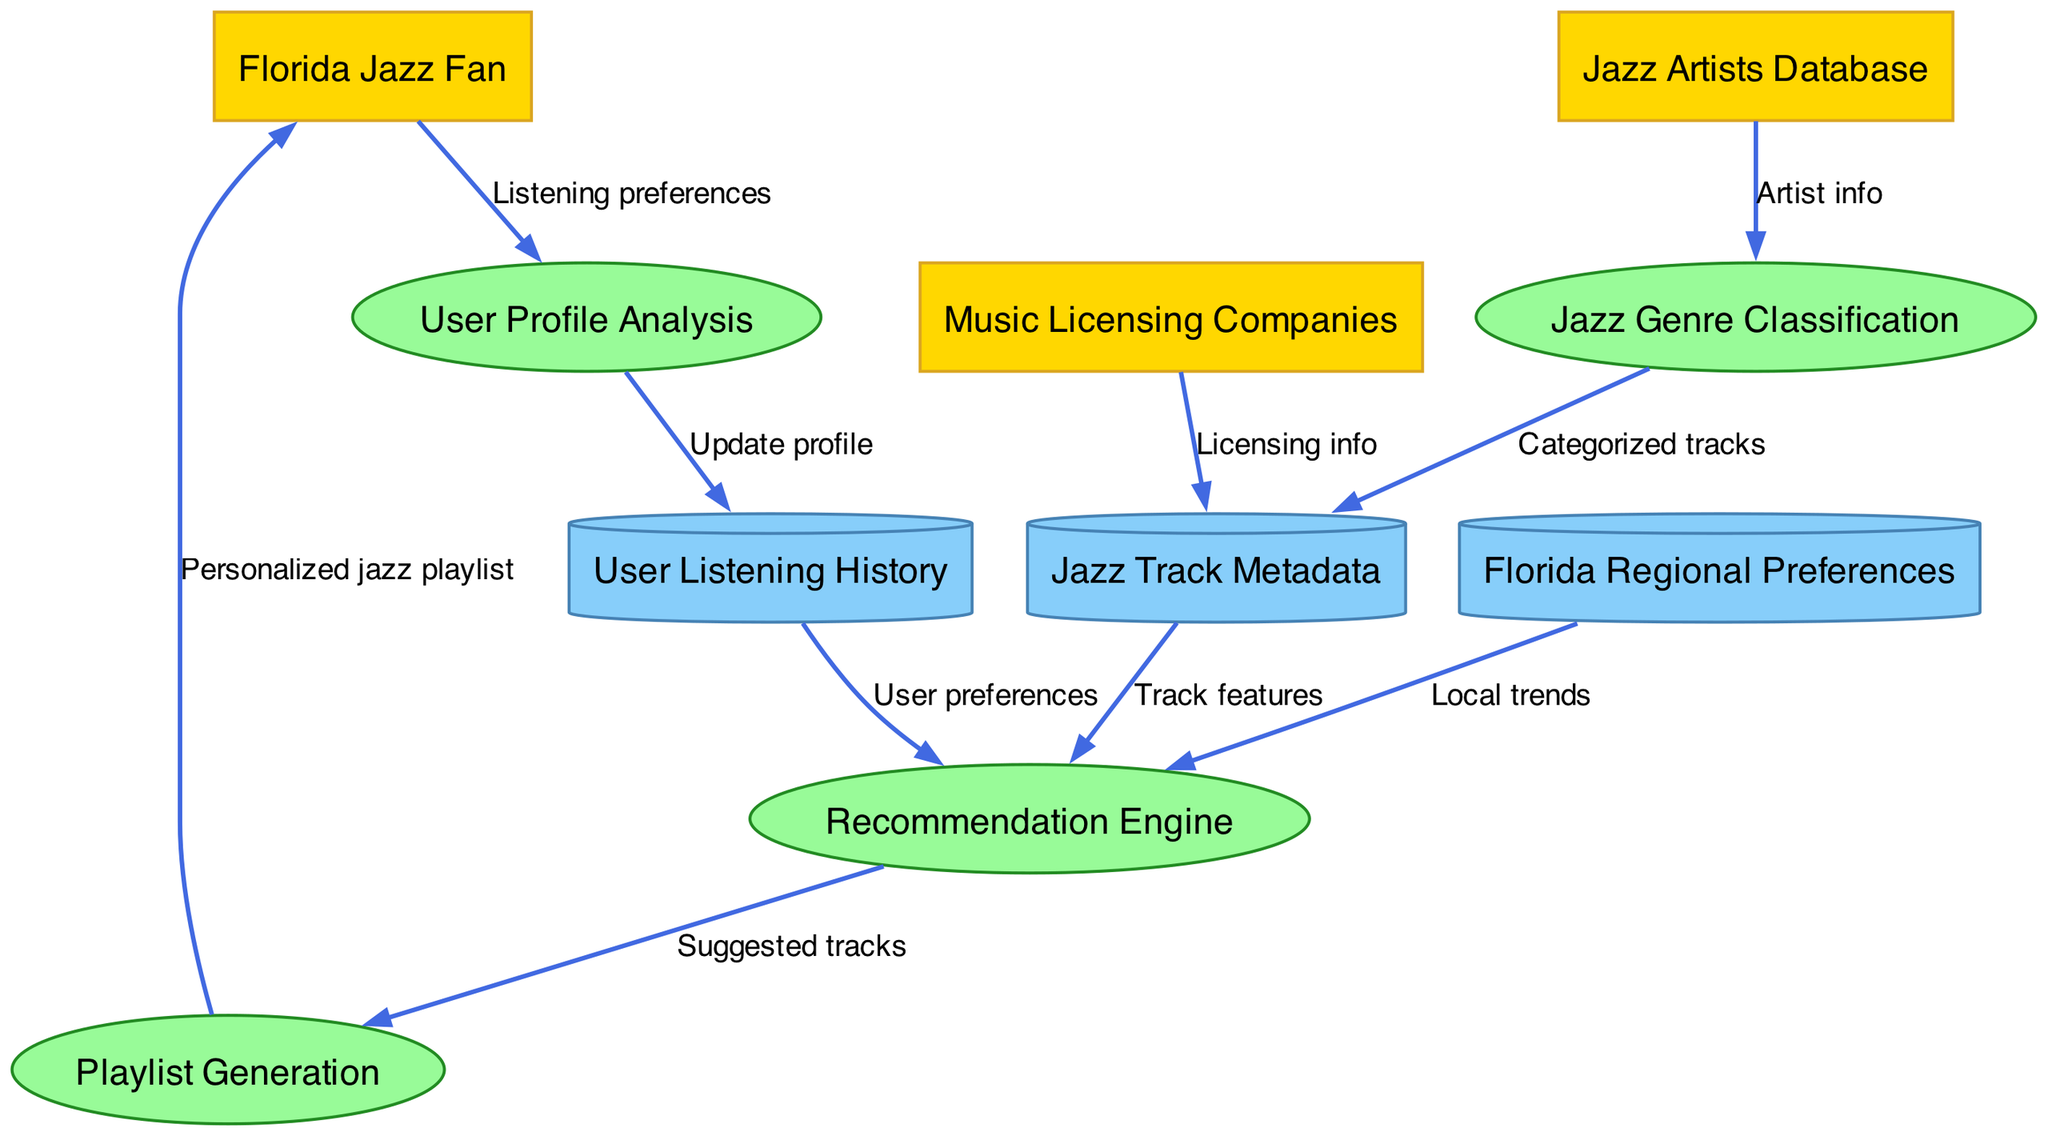What external entity provides listening preferences? The diagram indicates that the "Florida Jazz Fan" is the external entity that provides "Listening preferences" to the "User Profile Analysis" process.
Answer: Florida Jazz Fan How many processes are present in the diagram? By counting the nodes labeled as processes, there are four distinct processes: "User Profile Analysis," "Jazz Genre Classification," "Recommendation Engine," and "Playlist Generation."
Answer: 4 What data store receives categorized tracks? The data flow shows that the "Jazz Genre Classification" process sends "Categorized tracks" to the "Jazz Track Metadata" data store.
Answer: Jazz Track Metadata Which process follows the recommendation engine? According to the diagram, the "Recommendation Engine" sends "Suggested tracks" to the "Playlist Generation" process next in the flow.
Answer: Playlist Generation What type of information is provided to the jazz track metadata by music licensing companies? The data flow indicates that "Music Licensing Companies" provide "Licensing info" to the "Jazz Track Metadata."
Answer: Licensing info How many external entities are there? The diagram lists three external entities: "Florida Jazz Fan," "Jazz Artists Database," and "Music Licensing Companies."
Answer: 3 What is the purpose of the user profile analysis process? Based on the diagram, the "User Profile Analysis" process receives "Listening preferences" from the "Florida Jazz Fan" and updates the profile in "User Listening History." This indicates the purpose is to analyze user profiles based on their listening habits.
Answer: Analyze user profiles Which data store is influenced by user preferences? The "User Listening History" data store is influenced by "User preferences" sent from the "User Listening History" to the "Recommendation Engine."
Answer: User Listening History What connects jazz genre classification and jazz track metadata? The flow indicates that "Categorized tracks" are passed from the "Jazz Genre Classification" process to the "Jazz Track Metadata" data store, creating a direct connection between those two processes.
Answer: Categorized tracks 